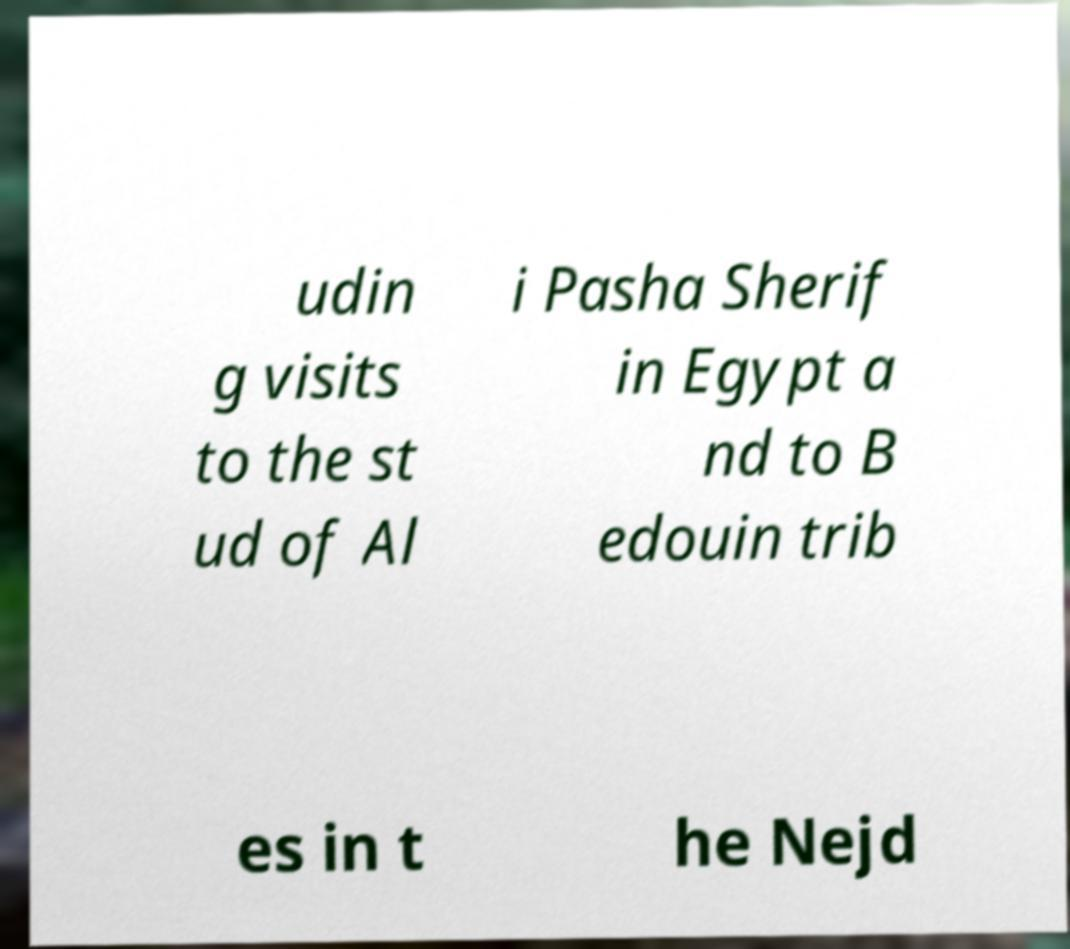Can you read and provide the text displayed in the image?This photo seems to have some interesting text. Can you extract and type it out for me? udin g visits to the st ud of Al i Pasha Sherif in Egypt a nd to B edouin trib es in t he Nejd 